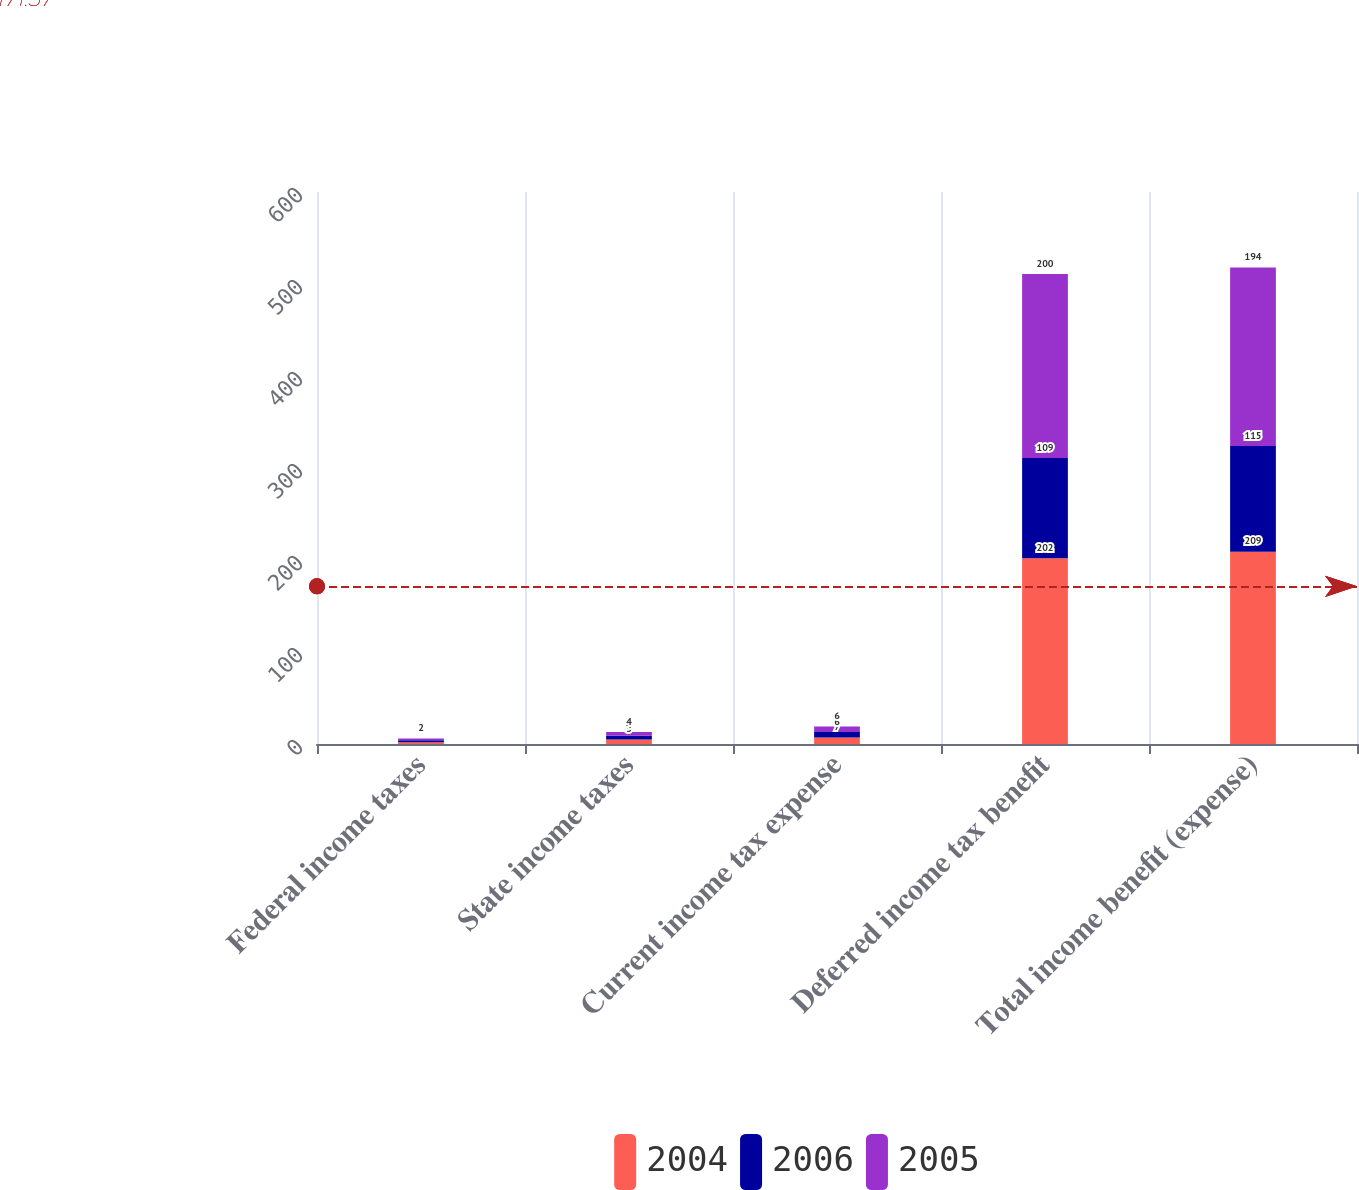<chart> <loc_0><loc_0><loc_500><loc_500><stacked_bar_chart><ecel><fcel>Federal income taxes<fcel>State income taxes<fcel>Current income tax expense<fcel>Deferred income tax benefit<fcel>Total income benefit (expense)<nl><fcel>2004<fcel>2<fcel>5<fcel>7<fcel>202<fcel>209<nl><fcel>2006<fcel>2<fcel>4<fcel>6<fcel>109<fcel>115<nl><fcel>2005<fcel>2<fcel>4<fcel>6<fcel>200<fcel>194<nl></chart> 